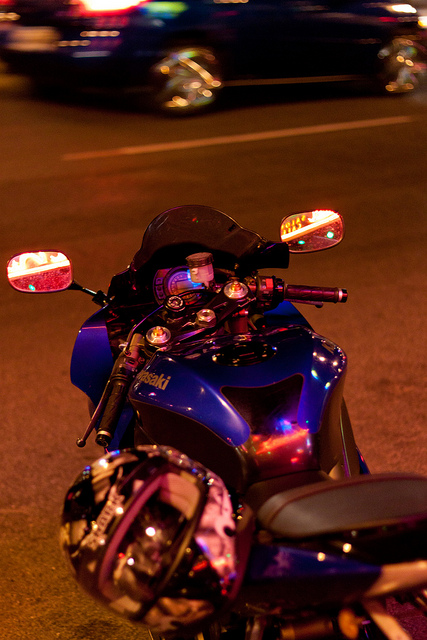<image>What color is the bikes pant? It is ambiguous because the bike does not wear pants. However, it can be seen as blue. What color is the bikes pant? I am not sure what color is the bike's pant. However, it can be seen blue. 